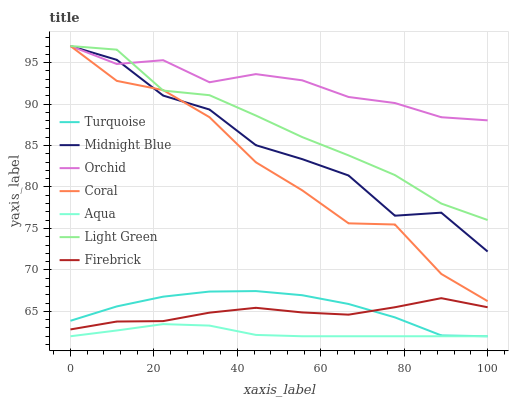Does Midnight Blue have the minimum area under the curve?
Answer yes or no. No. Does Midnight Blue have the maximum area under the curve?
Answer yes or no. No. Is Coral the smoothest?
Answer yes or no. No. Is Coral the roughest?
Answer yes or no. No. Does Midnight Blue have the lowest value?
Answer yes or no. No. Does Aqua have the highest value?
Answer yes or no. No. Is Turquoise less than Coral?
Answer yes or no. Yes. Is Coral greater than Turquoise?
Answer yes or no. Yes. Does Turquoise intersect Coral?
Answer yes or no. No. 